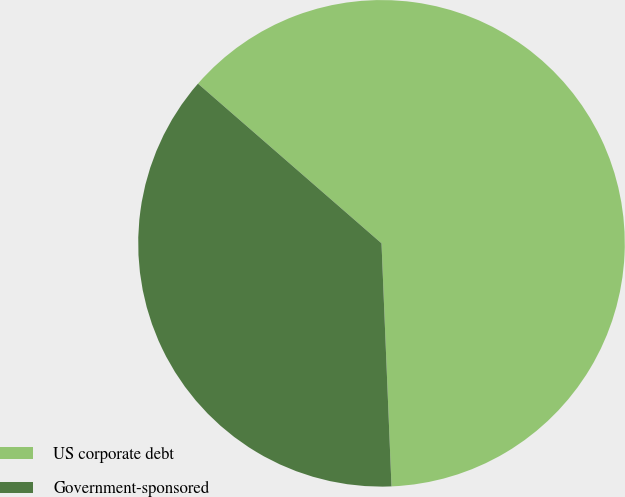Convert chart to OTSL. <chart><loc_0><loc_0><loc_500><loc_500><pie_chart><fcel>US corporate debt<fcel>Government-sponsored<nl><fcel>62.95%<fcel>37.05%<nl></chart> 